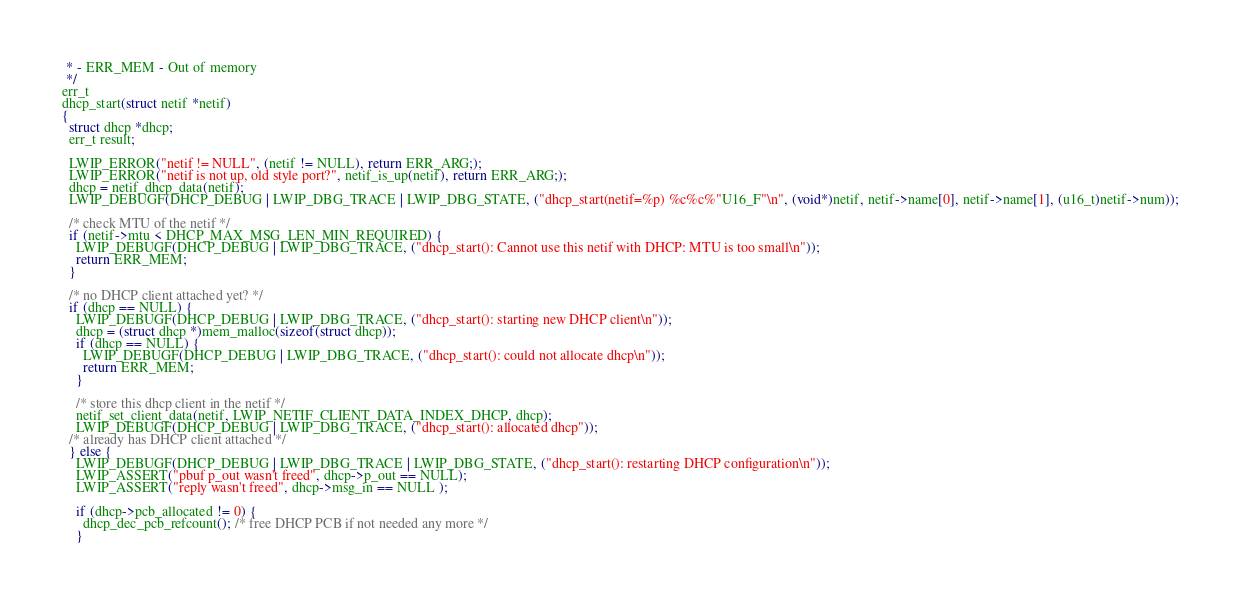Convert code to text. <code><loc_0><loc_0><loc_500><loc_500><_C_> * - ERR_MEM - Out of memory
 */
err_t
dhcp_start(struct netif *netif)
{
  struct dhcp *dhcp;
  err_t result;

  LWIP_ERROR("netif != NULL", (netif != NULL), return ERR_ARG;);
  LWIP_ERROR("netif is not up, old style port?", netif_is_up(netif), return ERR_ARG;);
  dhcp = netif_dhcp_data(netif);
  LWIP_DEBUGF(DHCP_DEBUG | LWIP_DBG_TRACE | LWIP_DBG_STATE, ("dhcp_start(netif=%p) %c%c%"U16_F"\n", (void*)netif, netif->name[0], netif->name[1], (u16_t)netif->num));

  /* check MTU of the netif */
  if (netif->mtu < DHCP_MAX_MSG_LEN_MIN_REQUIRED) {
    LWIP_DEBUGF(DHCP_DEBUG | LWIP_DBG_TRACE, ("dhcp_start(): Cannot use this netif with DHCP: MTU is too small\n"));
    return ERR_MEM;
  }

  /* no DHCP client attached yet? */
  if (dhcp == NULL) {
    LWIP_DEBUGF(DHCP_DEBUG | LWIP_DBG_TRACE, ("dhcp_start(): starting new DHCP client\n"));
    dhcp = (struct dhcp *)mem_malloc(sizeof(struct dhcp));
    if (dhcp == NULL) {
      LWIP_DEBUGF(DHCP_DEBUG | LWIP_DBG_TRACE, ("dhcp_start(): could not allocate dhcp\n"));
      return ERR_MEM;
    }

    /* store this dhcp client in the netif */
    netif_set_client_data(netif, LWIP_NETIF_CLIENT_DATA_INDEX_DHCP, dhcp);
    LWIP_DEBUGF(DHCP_DEBUG | LWIP_DBG_TRACE, ("dhcp_start(): allocated dhcp"));
  /* already has DHCP client attached */
  } else {
    LWIP_DEBUGF(DHCP_DEBUG | LWIP_DBG_TRACE | LWIP_DBG_STATE, ("dhcp_start(): restarting DHCP configuration\n"));
    LWIP_ASSERT("pbuf p_out wasn't freed", dhcp->p_out == NULL);
    LWIP_ASSERT("reply wasn't freed", dhcp->msg_in == NULL );

    if (dhcp->pcb_allocated != 0) {
      dhcp_dec_pcb_refcount(); /* free DHCP PCB if not needed any more */
    }</code> 